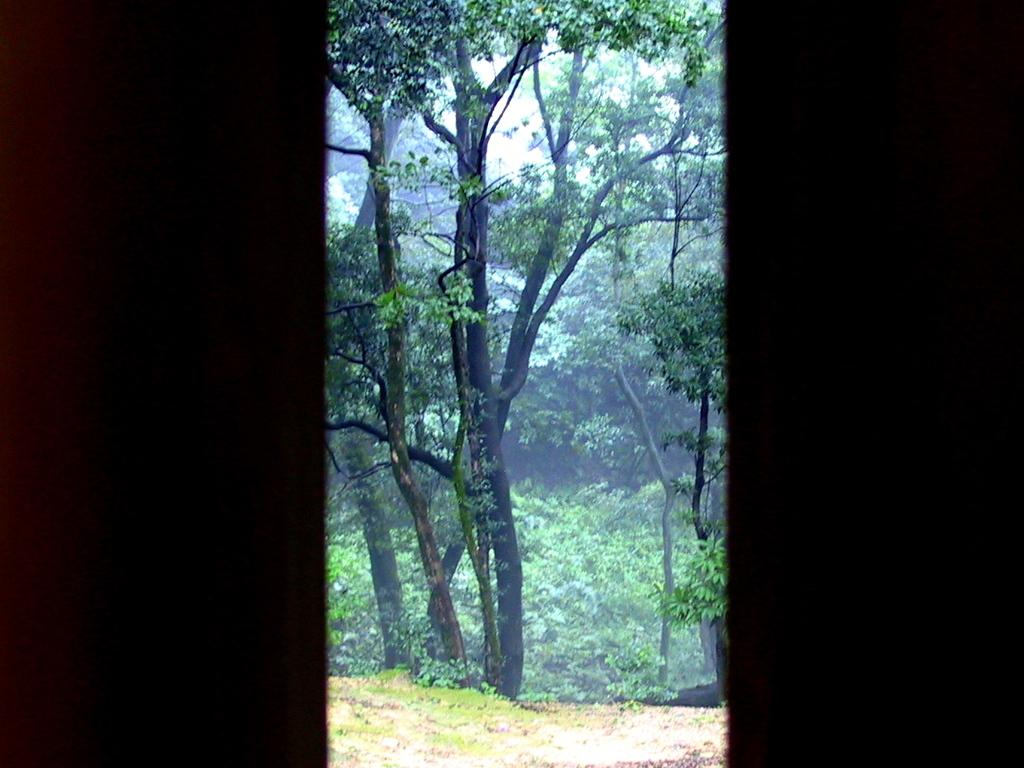What is the lighting condition on the right and left sides of the image? The right side and left side of the image are dark. What can be seen in the center of the image? There are trees in the center of the image. What type of terrain is visible at the bottom of the image? There is sand and grass at the bottom of the image. Where is the quarter placed on the tray in the image? There is no quarter or tray present in the image. What type of fan is visible in the image? There is no fan present in the image. 